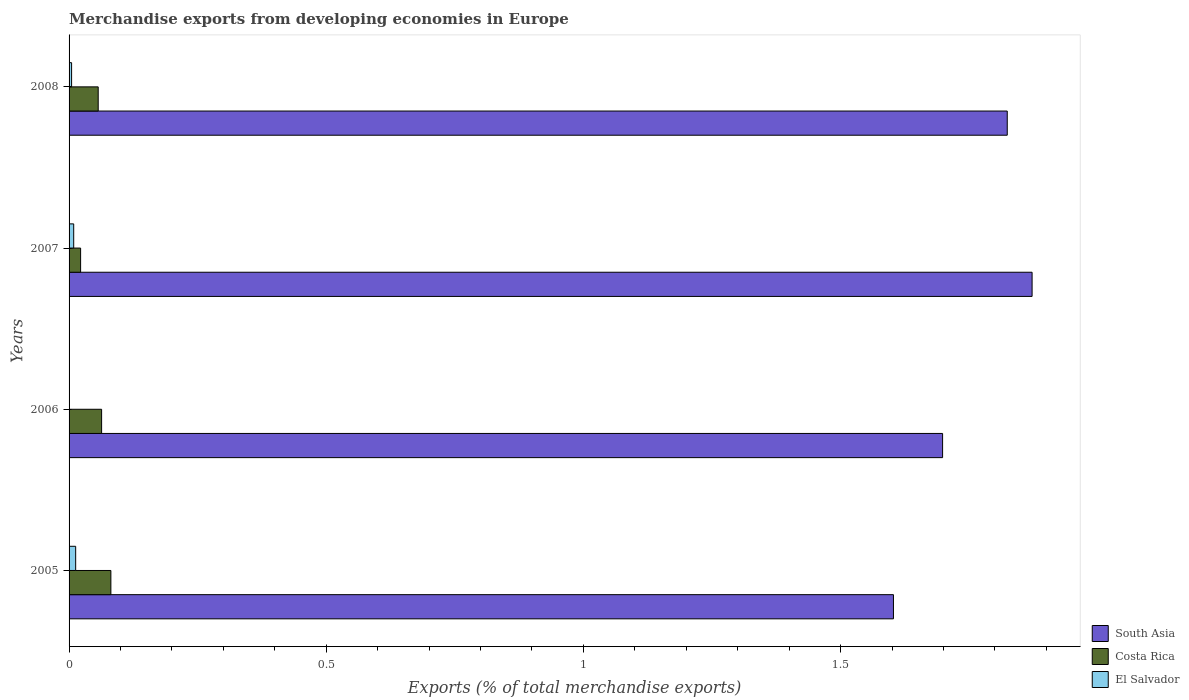How many different coloured bars are there?
Keep it short and to the point. 3. In how many cases, is the number of bars for a given year not equal to the number of legend labels?
Make the answer very short. 0. What is the percentage of total merchandise exports in Costa Rica in 2005?
Your answer should be very brief. 0.08. Across all years, what is the maximum percentage of total merchandise exports in South Asia?
Your answer should be compact. 1.87. Across all years, what is the minimum percentage of total merchandise exports in South Asia?
Give a very brief answer. 1.6. In which year was the percentage of total merchandise exports in Costa Rica maximum?
Give a very brief answer. 2005. In which year was the percentage of total merchandise exports in Costa Rica minimum?
Make the answer very short. 2007. What is the total percentage of total merchandise exports in Costa Rica in the graph?
Provide a succinct answer. 0.22. What is the difference between the percentage of total merchandise exports in El Salvador in 2006 and that in 2008?
Give a very brief answer. -0. What is the difference between the percentage of total merchandise exports in Costa Rica in 2008 and the percentage of total merchandise exports in El Salvador in 2007?
Your response must be concise. 0.05. What is the average percentage of total merchandise exports in South Asia per year?
Provide a short and direct response. 1.75. In the year 2005, what is the difference between the percentage of total merchandise exports in Costa Rica and percentage of total merchandise exports in South Asia?
Your answer should be compact. -1.52. What is the ratio of the percentage of total merchandise exports in South Asia in 2005 to that in 2008?
Offer a very short reply. 0.88. Is the difference between the percentage of total merchandise exports in Costa Rica in 2007 and 2008 greater than the difference between the percentage of total merchandise exports in South Asia in 2007 and 2008?
Your answer should be very brief. No. What is the difference between the highest and the second highest percentage of total merchandise exports in El Salvador?
Offer a terse response. 0. What is the difference between the highest and the lowest percentage of total merchandise exports in Costa Rica?
Your answer should be compact. 0.06. In how many years, is the percentage of total merchandise exports in South Asia greater than the average percentage of total merchandise exports in South Asia taken over all years?
Offer a terse response. 2. What does the 1st bar from the top in 2007 represents?
Make the answer very short. El Salvador. What is the difference between two consecutive major ticks on the X-axis?
Provide a short and direct response. 0.5. How many legend labels are there?
Provide a succinct answer. 3. How are the legend labels stacked?
Provide a short and direct response. Vertical. What is the title of the graph?
Your response must be concise. Merchandise exports from developing economies in Europe. What is the label or title of the X-axis?
Provide a short and direct response. Exports (% of total merchandise exports). What is the label or title of the Y-axis?
Your answer should be very brief. Years. What is the Exports (% of total merchandise exports) in South Asia in 2005?
Offer a very short reply. 1.6. What is the Exports (% of total merchandise exports) in Costa Rica in 2005?
Offer a very short reply. 0.08. What is the Exports (% of total merchandise exports) of El Salvador in 2005?
Make the answer very short. 0.01. What is the Exports (% of total merchandise exports) of South Asia in 2006?
Provide a short and direct response. 1.7. What is the Exports (% of total merchandise exports) of Costa Rica in 2006?
Offer a terse response. 0.06. What is the Exports (% of total merchandise exports) of El Salvador in 2006?
Ensure brevity in your answer.  0. What is the Exports (% of total merchandise exports) in South Asia in 2007?
Your answer should be compact. 1.87. What is the Exports (% of total merchandise exports) of Costa Rica in 2007?
Make the answer very short. 0.02. What is the Exports (% of total merchandise exports) of El Salvador in 2007?
Make the answer very short. 0.01. What is the Exports (% of total merchandise exports) of South Asia in 2008?
Offer a very short reply. 1.82. What is the Exports (% of total merchandise exports) of Costa Rica in 2008?
Your answer should be very brief. 0.06. What is the Exports (% of total merchandise exports) in El Salvador in 2008?
Offer a very short reply. 0. Across all years, what is the maximum Exports (% of total merchandise exports) of South Asia?
Offer a terse response. 1.87. Across all years, what is the maximum Exports (% of total merchandise exports) of Costa Rica?
Provide a short and direct response. 0.08. Across all years, what is the maximum Exports (% of total merchandise exports) of El Salvador?
Provide a short and direct response. 0.01. Across all years, what is the minimum Exports (% of total merchandise exports) of South Asia?
Give a very brief answer. 1.6. Across all years, what is the minimum Exports (% of total merchandise exports) of Costa Rica?
Offer a very short reply. 0.02. Across all years, what is the minimum Exports (% of total merchandise exports) in El Salvador?
Ensure brevity in your answer.  0. What is the total Exports (% of total merchandise exports) of South Asia in the graph?
Give a very brief answer. 7. What is the total Exports (% of total merchandise exports) in Costa Rica in the graph?
Your answer should be compact. 0.22. What is the total Exports (% of total merchandise exports) in El Salvador in the graph?
Keep it short and to the point. 0.03. What is the difference between the Exports (% of total merchandise exports) in South Asia in 2005 and that in 2006?
Ensure brevity in your answer.  -0.1. What is the difference between the Exports (% of total merchandise exports) in Costa Rica in 2005 and that in 2006?
Ensure brevity in your answer.  0.02. What is the difference between the Exports (% of total merchandise exports) of El Salvador in 2005 and that in 2006?
Your answer should be compact. 0.01. What is the difference between the Exports (% of total merchandise exports) in South Asia in 2005 and that in 2007?
Your response must be concise. -0.27. What is the difference between the Exports (% of total merchandise exports) in Costa Rica in 2005 and that in 2007?
Make the answer very short. 0.06. What is the difference between the Exports (% of total merchandise exports) in El Salvador in 2005 and that in 2007?
Your answer should be very brief. 0. What is the difference between the Exports (% of total merchandise exports) of South Asia in 2005 and that in 2008?
Provide a succinct answer. -0.22. What is the difference between the Exports (% of total merchandise exports) in Costa Rica in 2005 and that in 2008?
Ensure brevity in your answer.  0.02. What is the difference between the Exports (% of total merchandise exports) in El Salvador in 2005 and that in 2008?
Offer a terse response. 0.01. What is the difference between the Exports (% of total merchandise exports) of South Asia in 2006 and that in 2007?
Provide a succinct answer. -0.17. What is the difference between the Exports (% of total merchandise exports) in Costa Rica in 2006 and that in 2007?
Provide a succinct answer. 0.04. What is the difference between the Exports (% of total merchandise exports) of El Salvador in 2006 and that in 2007?
Offer a very short reply. -0.01. What is the difference between the Exports (% of total merchandise exports) of South Asia in 2006 and that in 2008?
Offer a very short reply. -0.13. What is the difference between the Exports (% of total merchandise exports) in Costa Rica in 2006 and that in 2008?
Make the answer very short. 0.01. What is the difference between the Exports (% of total merchandise exports) in El Salvador in 2006 and that in 2008?
Provide a succinct answer. -0. What is the difference between the Exports (% of total merchandise exports) of South Asia in 2007 and that in 2008?
Give a very brief answer. 0.05. What is the difference between the Exports (% of total merchandise exports) of Costa Rica in 2007 and that in 2008?
Provide a succinct answer. -0.03. What is the difference between the Exports (% of total merchandise exports) of El Salvador in 2007 and that in 2008?
Provide a succinct answer. 0. What is the difference between the Exports (% of total merchandise exports) of South Asia in 2005 and the Exports (% of total merchandise exports) of Costa Rica in 2006?
Your answer should be compact. 1.54. What is the difference between the Exports (% of total merchandise exports) of South Asia in 2005 and the Exports (% of total merchandise exports) of El Salvador in 2006?
Provide a succinct answer. 1.6. What is the difference between the Exports (% of total merchandise exports) in Costa Rica in 2005 and the Exports (% of total merchandise exports) in El Salvador in 2006?
Keep it short and to the point. 0.08. What is the difference between the Exports (% of total merchandise exports) in South Asia in 2005 and the Exports (% of total merchandise exports) in Costa Rica in 2007?
Give a very brief answer. 1.58. What is the difference between the Exports (% of total merchandise exports) in South Asia in 2005 and the Exports (% of total merchandise exports) in El Salvador in 2007?
Provide a short and direct response. 1.59. What is the difference between the Exports (% of total merchandise exports) in Costa Rica in 2005 and the Exports (% of total merchandise exports) in El Salvador in 2007?
Your response must be concise. 0.07. What is the difference between the Exports (% of total merchandise exports) of South Asia in 2005 and the Exports (% of total merchandise exports) of Costa Rica in 2008?
Ensure brevity in your answer.  1.55. What is the difference between the Exports (% of total merchandise exports) in South Asia in 2005 and the Exports (% of total merchandise exports) in El Salvador in 2008?
Offer a terse response. 1.6. What is the difference between the Exports (% of total merchandise exports) in Costa Rica in 2005 and the Exports (% of total merchandise exports) in El Salvador in 2008?
Give a very brief answer. 0.08. What is the difference between the Exports (% of total merchandise exports) of South Asia in 2006 and the Exports (% of total merchandise exports) of Costa Rica in 2007?
Ensure brevity in your answer.  1.68. What is the difference between the Exports (% of total merchandise exports) in South Asia in 2006 and the Exports (% of total merchandise exports) in El Salvador in 2007?
Make the answer very short. 1.69. What is the difference between the Exports (% of total merchandise exports) in Costa Rica in 2006 and the Exports (% of total merchandise exports) in El Salvador in 2007?
Provide a succinct answer. 0.05. What is the difference between the Exports (% of total merchandise exports) in South Asia in 2006 and the Exports (% of total merchandise exports) in Costa Rica in 2008?
Offer a terse response. 1.64. What is the difference between the Exports (% of total merchandise exports) in South Asia in 2006 and the Exports (% of total merchandise exports) in El Salvador in 2008?
Offer a terse response. 1.69. What is the difference between the Exports (% of total merchandise exports) in Costa Rica in 2006 and the Exports (% of total merchandise exports) in El Salvador in 2008?
Give a very brief answer. 0.06. What is the difference between the Exports (% of total merchandise exports) in South Asia in 2007 and the Exports (% of total merchandise exports) in Costa Rica in 2008?
Provide a succinct answer. 1.82. What is the difference between the Exports (% of total merchandise exports) in South Asia in 2007 and the Exports (% of total merchandise exports) in El Salvador in 2008?
Keep it short and to the point. 1.87. What is the difference between the Exports (% of total merchandise exports) in Costa Rica in 2007 and the Exports (% of total merchandise exports) in El Salvador in 2008?
Ensure brevity in your answer.  0.02. What is the average Exports (% of total merchandise exports) of South Asia per year?
Give a very brief answer. 1.75. What is the average Exports (% of total merchandise exports) in Costa Rica per year?
Give a very brief answer. 0.06. What is the average Exports (% of total merchandise exports) of El Salvador per year?
Offer a very short reply. 0.01. In the year 2005, what is the difference between the Exports (% of total merchandise exports) in South Asia and Exports (% of total merchandise exports) in Costa Rica?
Your response must be concise. 1.52. In the year 2005, what is the difference between the Exports (% of total merchandise exports) of South Asia and Exports (% of total merchandise exports) of El Salvador?
Your answer should be very brief. 1.59. In the year 2005, what is the difference between the Exports (% of total merchandise exports) in Costa Rica and Exports (% of total merchandise exports) in El Salvador?
Provide a succinct answer. 0.07. In the year 2006, what is the difference between the Exports (% of total merchandise exports) in South Asia and Exports (% of total merchandise exports) in Costa Rica?
Your response must be concise. 1.64. In the year 2006, what is the difference between the Exports (% of total merchandise exports) in South Asia and Exports (% of total merchandise exports) in El Salvador?
Your answer should be very brief. 1.7. In the year 2006, what is the difference between the Exports (% of total merchandise exports) of Costa Rica and Exports (% of total merchandise exports) of El Salvador?
Your response must be concise. 0.06. In the year 2007, what is the difference between the Exports (% of total merchandise exports) of South Asia and Exports (% of total merchandise exports) of Costa Rica?
Offer a terse response. 1.85. In the year 2007, what is the difference between the Exports (% of total merchandise exports) in South Asia and Exports (% of total merchandise exports) in El Salvador?
Your answer should be very brief. 1.86. In the year 2007, what is the difference between the Exports (% of total merchandise exports) of Costa Rica and Exports (% of total merchandise exports) of El Salvador?
Your response must be concise. 0.01. In the year 2008, what is the difference between the Exports (% of total merchandise exports) in South Asia and Exports (% of total merchandise exports) in Costa Rica?
Provide a short and direct response. 1.77. In the year 2008, what is the difference between the Exports (% of total merchandise exports) in South Asia and Exports (% of total merchandise exports) in El Salvador?
Provide a succinct answer. 1.82. In the year 2008, what is the difference between the Exports (% of total merchandise exports) of Costa Rica and Exports (% of total merchandise exports) of El Salvador?
Offer a very short reply. 0.05. What is the ratio of the Exports (% of total merchandise exports) in South Asia in 2005 to that in 2006?
Offer a terse response. 0.94. What is the ratio of the Exports (% of total merchandise exports) of Costa Rica in 2005 to that in 2006?
Your answer should be very brief. 1.28. What is the ratio of the Exports (% of total merchandise exports) of El Salvador in 2005 to that in 2006?
Offer a terse response. 26.35. What is the ratio of the Exports (% of total merchandise exports) of South Asia in 2005 to that in 2007?
Give a very brief answer. 0.86. What is the ratio of the Exports (% of total merchandise exports) in Costa Rica in 2005 to that in 2007?
Provide a succinct answer. 3.62. What is the ratio of the Exports (% of total merchandise exports) in El Salvador in 2005 to that in 2007?
Keep it short and to the point. 1.43. What is the ratio of the Exports (% of total merchandise exports) of South Asia in 2005 to that in 2008?
Keep it short and to the point. 0.88. What is the ratio of the Exports (% of total merchandise exports) of Costa Rica in 2005 to that in 2008?
Provide a succinct answer. 1.44. What is the ratio of the Exports (% of total merchandise exports) in El Salvador in 2005 to that in 2008?
Make the answer very short. 2.61. What is the ratio of the Exports (% of total merchandise exports) of South Asia in 2006 to that in 2007?
Your answer should be very brief. 0.91. What is the ratio of the Exports (% of total merchandise exports) in Costa Rica in 2006 to that in 2007?
Your answer should be very brief. 2.82. What is the ratio of the Exports (% of total merchandise exports) in El Salvador in 2006 to that in 2007?
Your answer should be very brief. 0.05. What is the ratio of the Exports (% of total merchandise exports) in South Asia in 2006 to that in 2008?
Offer a terse response. 0.93. What is the ratio of the Exports (% of total merchandise exports) in Costa Rica in 2006 to that in 2008?
Your response must be concise. 1.12. What is the ratio of the Exports (% of total merchandise exports) of El Salvador in 2006 to that in 2008?
Make the answer very short. 0.1. What is the ratio of the Exports (% of total merchandise exports) in South Asia in 2007 to that in 2008?
Offer a terse response. 1.03. What is the ratio of the Exports (% of total merchandise exports) in Costa Rica in 2007 to that in 2008?
Offer a terse response. 0.4. What is the ratio of the Exports (% of total merchandise exports) in El Salvador in 2007 to that in 2008?
Give a very brief answer. 1.83. What is the difference between the highest and the second highest Exports (% of total merchandise exports) of South Asia?
Provide a short and direct response. 0.05. What is the difference between the highest and the second highest Exports (% of total merchandise exports) in Costa Rica?
Give a very brief answer. 0.02. What is the difference between the highest and the second highest Exports (% of total merchandise exports) in El Salvador?
Your response must be concise. 0. What is the difference between the highest and the lowest Exports (% of total merchandise exports) of South Asia?
Make the answer very short. 0.27. What is the difference between the highest and the lowest Exports (% of total merchandise exports) of Costa Rica?
Keep it short and to the point. 0.06. What is the difference between the highest and the lowest Exports (% of total merchandise exports) of El Salvador?
Ensure brevity in your answer.  0.01. 